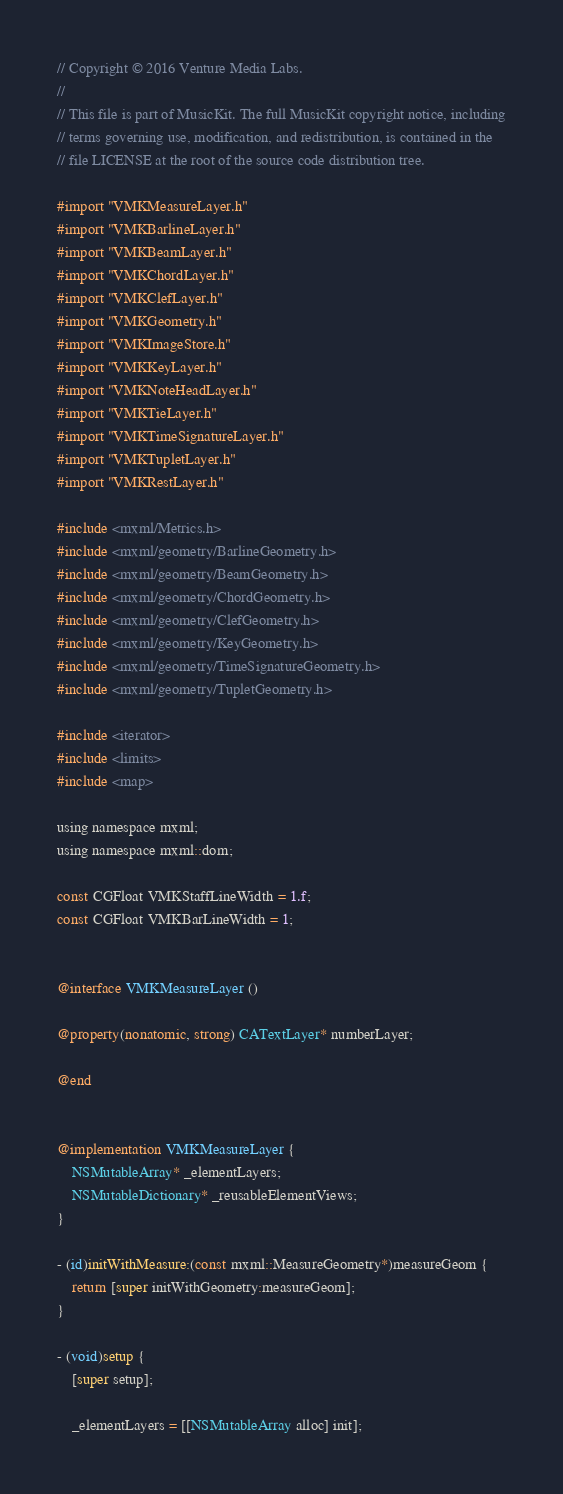Convert code to text. <code><loc_0><loc_0><loc_500><loc_500><_ObjectiveC_>// Copyright © 2016 Venture Media Labs.
//
// This file is part of MusicKit. The full MusicKit copyright notice, including
// terms governing use, modification, and redistribution, is contained in the
// file LICENSE at the root of the source code distribution tree.

#import "VMKMeasureLayer.h"
#import "VMKBarlineLayer.h"
#import "VMKBeamLayer.h"
#import "VMKChordLayer.h"
#import "VMKClefLayer.h"
#import "VMKGeometry.h"
#import "VMKImageStore.h"
#import "VMKKeyLayer.h"
#import "VMKNoteHeadLayer.h"
#import "VMKTieLayer.h"
#import "VMKTimeSignatureLayer.h"
#import "VMKTupletLayer.h"
#import "VMKRestLayer.h"

#include <mxml/Metrics.h>
#include <mxml/geometry/BarlineGeometry.h>
#include <mxml/geometry/BeamGeometry.h>
#include <mxml/geometry/ChordGeometry.h>
#include <mxml/geometry/ClefGeometry.h>
#include <mxml/geometry/KeyGeometry.h>
#include <mxml/geometry/TimeSignatureGeometry.h>
#include <mxml/geometry/TupletGeometry.h>

#include <iterator>
#include <limits>
#include <map>

using namespace mxml;
using namespace mxml::dom;

const CGFloat VMKStaffLineWidth = 1.f;
const CGFloat VMKBarLineWidth = 1;


@interface VMKMeasureLayer ()

@property(nonatomic, strong) CATextLayer* numberLayer;

@end


@implementation VMKMeasureLayer {
    NSMutableArray* _elementLayers;
    NSMutableDictionary* _reusableElementViews;
}

- (id)initWithMeasure:(const mxml::MeasureGeometry*)measureGeom {
    return [super initWithGeometry:measureGeom];
}

- (void)setup {
    [super setup];

    _elementLayers = [[NSMutableArray alloc] init];</code> 